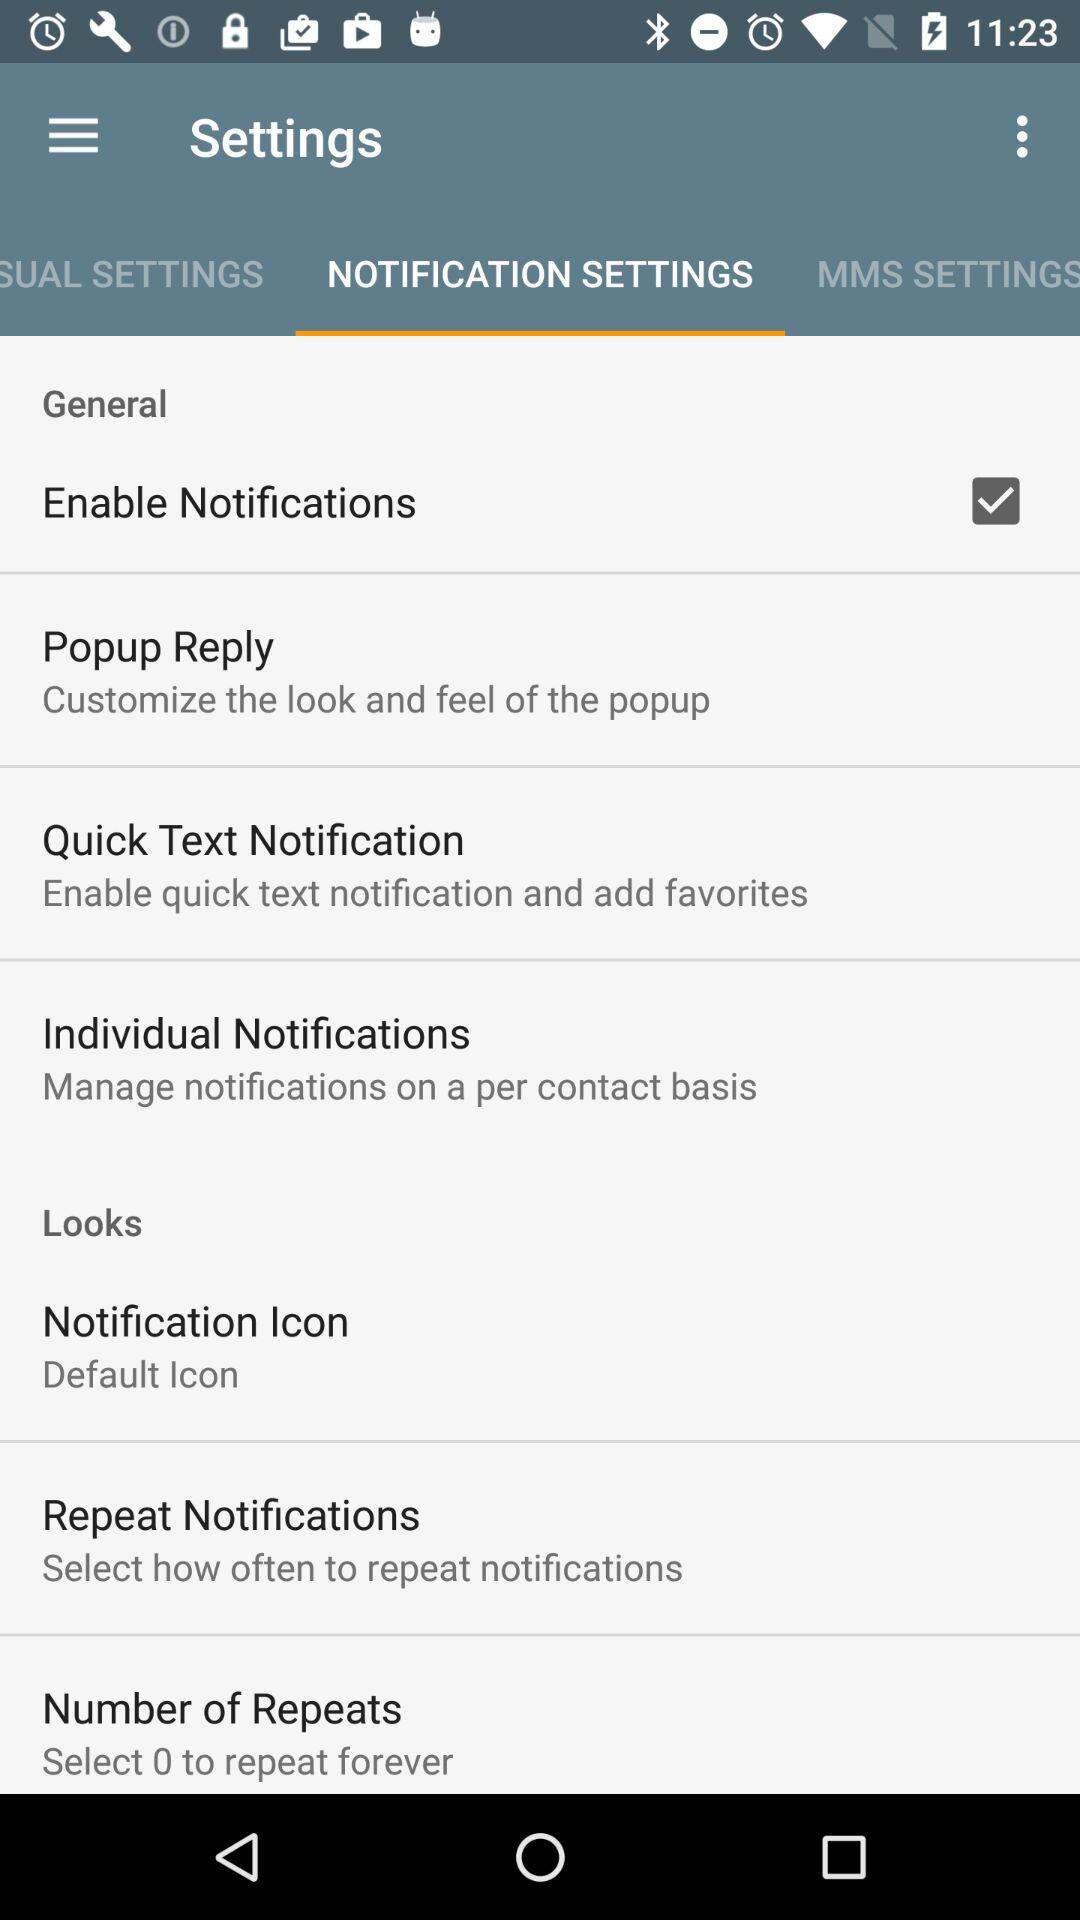Which tab is open? The open tab is "NOTIFICATION SETTINGS". 